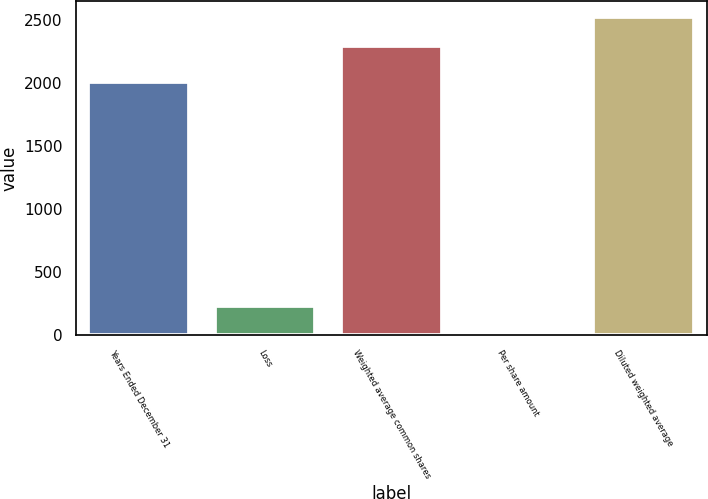Convert chart. <chart><loc_0><loc_0><loc_500><loc_500><bar_chart><fcel>Years Ended December 31<fcel>Loss<fcel>Weighted average common shares<fcel>Per share amount<fcel>Diluted weighted average<nl><fcel>2009<fcel>229.6<fcel>2295.6<fcel>0.05<fcel>2525.15<nl></chart> 